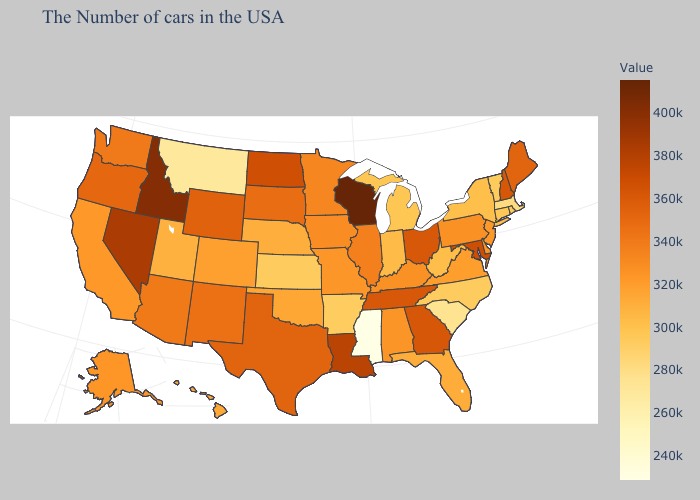Does the map have missing data?
Quick response, please. No. Which states have the lowest value in the USA?
Answer briefly. Mississippi. Does Wisconsin have the highest value in the USA?
Short answer required. Yes. Among the states that border Colorado , does Wyoming have the highest value?
Quick response, please. Yes. Does Wisconsin have a lower value than Connecticut?
Answer briefly. No. Which states have the highest value in the USA?
Keep it brief. Wisconsin. Does Kansas have the lowest value in the MidWest?
Keep it brief. Yes. Among the states that border Rhode Island , which have the highest value?
Be succinct. Connecticut. 